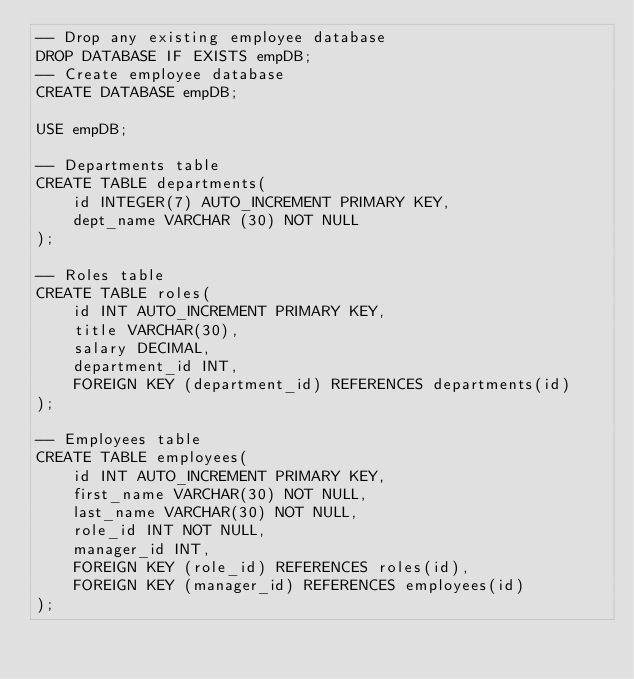Convert code to text. <code><loc_0><loc_0><loc_500><loc_500><_SQL_>-- Drop any existing employee database 
DROP DATABASE IF EXISTS empDB;
-- Create employee database
CREATE DATABASE empDB;

USE empDB;

-- Departments table
CREATE TABLE departments(
    id INTEGER(7) AUTO_INCREMENT PRIMARY KEY,
    dept_name VARCHAR (30) NOT NULL
);

-- Roles table
CREATE TABLE roles(
    id INT AUTO_INCREMENT PRIMARY KEY,
    title VARCHAR(30),
    salary DECIMAL,
    department_id INT,
    FOREIGN KEY (department_id) REFERENCES departments(id)
);

-- Employees table
CREATE TABLE employees(
    id INT AUTO_INCREMENT PRIMARY KEY,
    first_name VARCHAR(30) NOT NULL,
    last_name VARCHAR(30) NOT NULL,
    role_id INT NOT NULL,
    manager_id INT,
    FOREIGN KEY (role_id) REFERENCES roles(id),
    FOREIGN KEY (manager_id) REFERENCES employees(id)
);</code> 